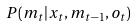<formula> <loc_0><loc_0><loc_500><loc_500>P ( m _ { t } | x _ { t } , m _ { t - 1 } , o _ { t } )</formula> 